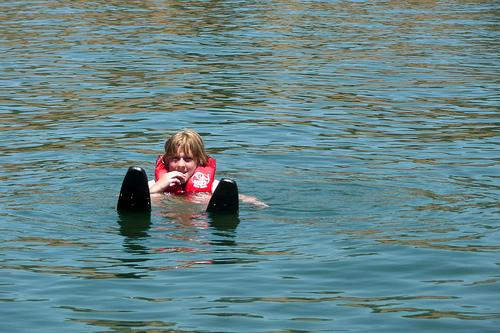Identify the color and type of object the boy is wearing on his feet. The boy is wearing black water skis. What are some noticeable features of the water's surface in the image? The water's surface has ripples, light reflections, and a reflection of the boy. What is the boy doing with his hand and how does it relate to his overall action? The boy has his hand in or near his mouth, which may be a reaction or adjustment to his activity of floating or swimming in the water. What type of body of water is the boy swimming in? The boy is swimming in a lake. Provide a brief description of the boy's hair and the safety equipment he is wearing. The boy has wet blonde hair and is wearing a red and white life vest. Describe the appearance of the young person's face in the image. The young person has blonde hair with bangs and shadows on their face. How would you describe the overall condition of the water in the image? The water is relatively calm with small waves and ripples, and appears clear and blue. What is the predominant color of the life vest the person is wearing, and does it have any markings? The predominant color of the life vest is red, and it has a white printed logo. In one sentence, describe the position of the boy in the water. The boy is laying backwards in the water, with his hand near his mouth and the bottom half of his body submerged. Mention an object in the image that indicates the boy's water sport activity. Black rubber water ski is present in the image, indicating the boy's water sport activity. Look for a yellow kayak floating near the boy in the water. Someone must have left their kayak unattended. Propose an exciting narrative about the boy in the image based on his activity and posture. A courageous, blonde-headed boy embarks on an adrenaline-pumping waterskiing adventure, fearlessly floating in the lake decorated with a red life vest as he prepares for takeoff. What color is the water ski in the image? Black Based on the image, can you tell whether the boy is in motion or stationary? Stationary What event can be detected from the image? A boy wearing water skis and a life vest floating in a lake Summarize the scene in a poetic manner. A blonde-headed youth floats gently on a tranquil lake, wearing water skis and cloaked in a vibrant red life vest, as shimmering ripples dance around their sunlit form. Identify the expression of the person in this image. Calm expression, hand near mouth Which of the following materials is the water ski made of? (A) wood (B) rubber (C) fiberglass B) rubber Can you notice the orange and black striped fish swimming around the boy's legs? It appears as if the fish wants to play with the boy. Is the person fully submerged in the water or partially submerged? Partially submerged Identify the girl wearing a purple dress and a straw hat, sitting on a beach chair near the water. The girl seems to be enjoying her sunny beach day. Can you deduce the level of water turbulence from the image? The water is relatively calm with small waves. Find the small green island in the background near the horizon. The island seems to have a tiny lighthouse on it to guide the boats. Considering the boy's posture and situation, what emotion is most likely being conveyed? Calm and relaxed What is the hair color of the person in the image? Blonde Choose the correct description: (A) girl swimming in a pool (B) boy floating in a lake with water skis and a life vest (C) a group of friends at the beach B) boy floating in a lake with water skis and a life vest Determine if a life vest is present in the image, and if so, describe its color(s). Yes, there is a red and white life vest. Are there any identifiable logos on the life preserver? Yes, there is a white printed logo on the life preserver. What can be detected from the boy's position in the water? The boy is laying backwards in the water, with the bottom half of his body submerged. Please identify any footwear worn by the person in the image. The boy's shoes are black. What hairstyle does the boy in the image have? Blonde hair with bangs Within the image, describe the action being performed by the boy. The boy is floating in water, wearing water skis and a life vest. Explain the state of the water in the image. The water is clear, blue, and relatively calm with small waves and light reflecting on it. Can you point out the green snorkeling mask positioned at the top-right corner of the image? The green snorkeling mask is hidden behind a coral reef. Do you see a group of people on the shore, taking photos of the boy in the water? They must be proud of the boy's water skiing adventure. 